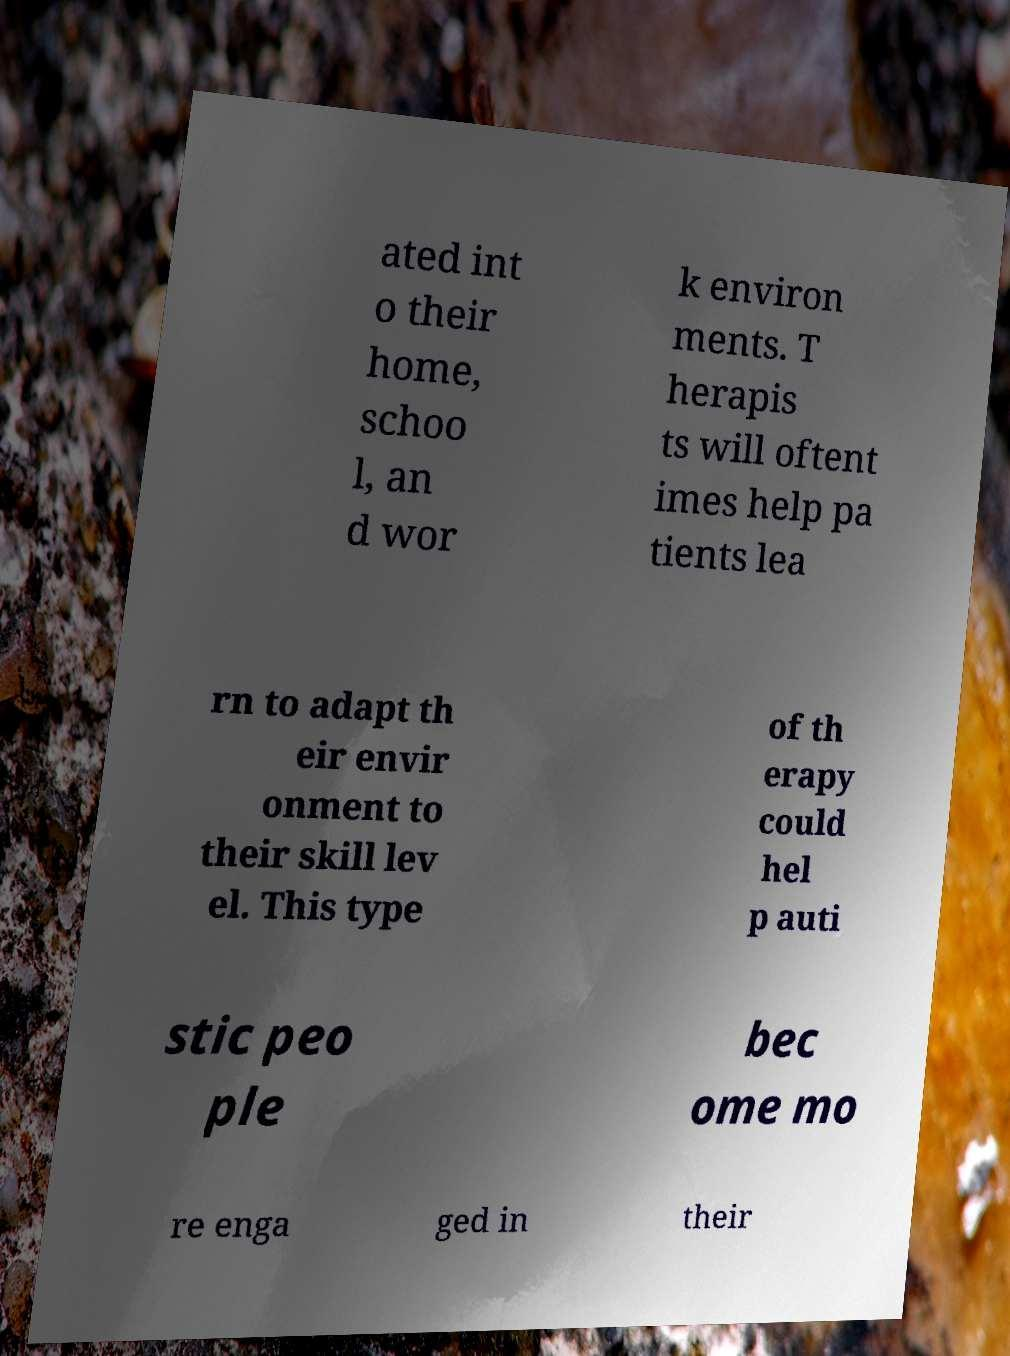Could you extract and type out the text from this image? ated int o their home, schoo l, an d wor k environ ments. T herapis ts will oftent imes help pa tients lea rn to adapt th eir envir onment to their skill lev el. This type of th erapy could hel p auti stic peo ple bec ome mo re enga ged in their 